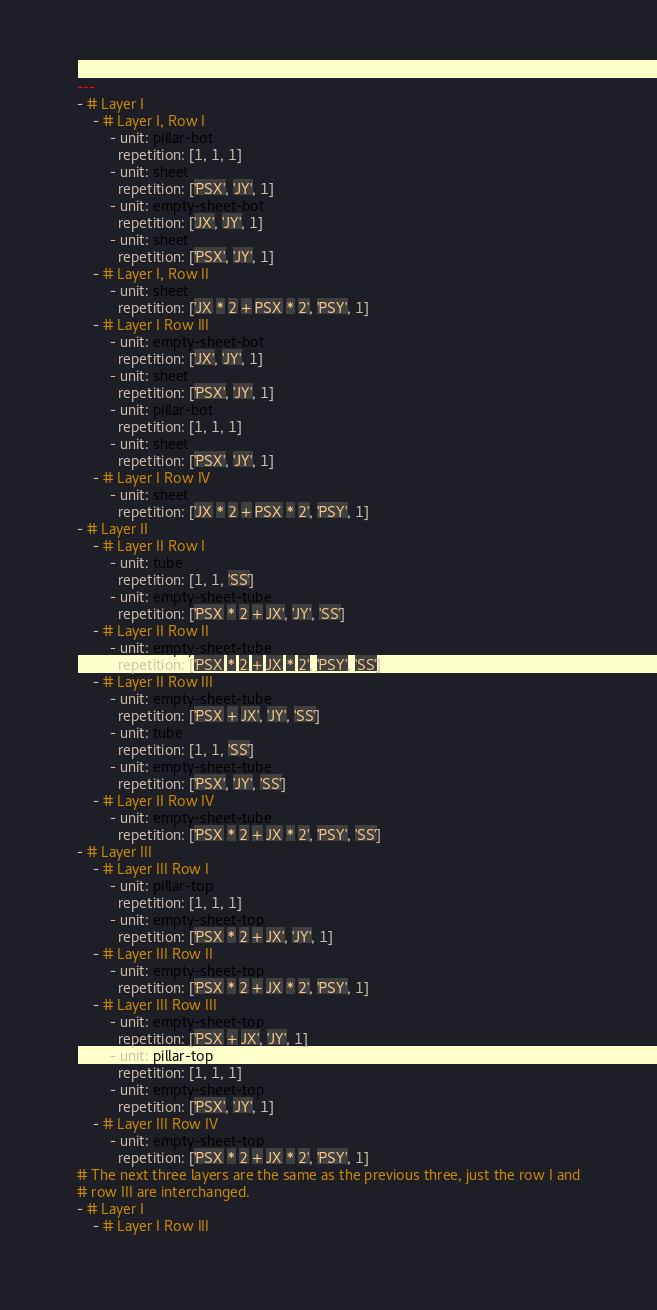<code> <loc_0><loc_0><loc_500><loc_500><_YAML_>---
- # Layer I
    - # Layer I, Row I
        - unit: pillar-bot
          repetition: [1, 1, 1]
        - unit: sheet
          repetition: ['PSX', 'JY', 1]
        - unit: empty-sheet-bot
          repetition: ['JX', 'JY', 1]
        - unit: sheet
          repetition: ['PSX', 'JY', 1]
    - # Layer I, Row II
        - unit: sheet
          repetition: ['JX * 2 + PSX * 2', 'PSY', 1]
    - # Layer I Row III
        - unit: empty-sheet-bot
          repetition: ['JX', 'JY', 1]
        - unit: sheet
          repetition: ['PSX', 'JY', 1]
        - unit: pillar-bot
          repetition: [1, 1, 1]
        - unit: sheet
          repetition: ['PSX', 'JY', 1]
    - # Layer I Row IV
        - unit: sheet
          repetition: ['JX * 2 + PSX * 2', 'PSY', 1]
- # Layer II 
    - # Layer II Row I
        - unit: tube
          repetition: [1, 1, 'SS']
        - unit: empty-sheet-tube
          repetition: ['PSX * 2 + JX', 'JY', 'SS']
    - # Layer II Row II
        - unit: empty-sheet-tube
          repetition: ['PSX * 2 + JX * 2', 'PSY', 'SS']
    - # Layer II Row III
        - unit: empty-sheet-tube
          repetition: ['PSX + JX', 'JY', 'SS']
        - unit: tube
          repetition: [1, 1, 'SS']
        - unit: empty-sheet-tube
          repetition: ['PSX', 'JY', 'SS']
    - # Layer II Row IV
        - unit: empty-sheet-tube
          repetition: ['PSX * 2 + JX * 2', 'PSY', 'SS']
- # Layer III
    - # Layer III Row I
        - unit: pillar-top
          repetition: [1, 1, 1]
        - unit: empty-sheet-top
          repetition: ['PSX * 2 + JX', 'JY', 1]
    - # Layer III Row II
        - unit: empty-sheet-top
          repetition: ['PSX * 2 + JX * 2', 'PSY', 1]
    - # Layer III Row III
        - unit: empty-sheet-top
          repetition: ['PSX + JX', 'JY', 1]
        - unit: pillar-top
          repetition: [1, 1, 1]
        - unit: empty-sheet-top
          repetition: ['PSX', 'JY', 1]
    - # Layer III Row IV
        - unit: empty-sheet-top
          repetition: ['PSX * 2 + JX * 2', 'PSY', 1]
# The next three layers are the same as the previous three, just the row I and
# row III are interchanged.
- # Layer I
    - # Layer I Row III</code> 